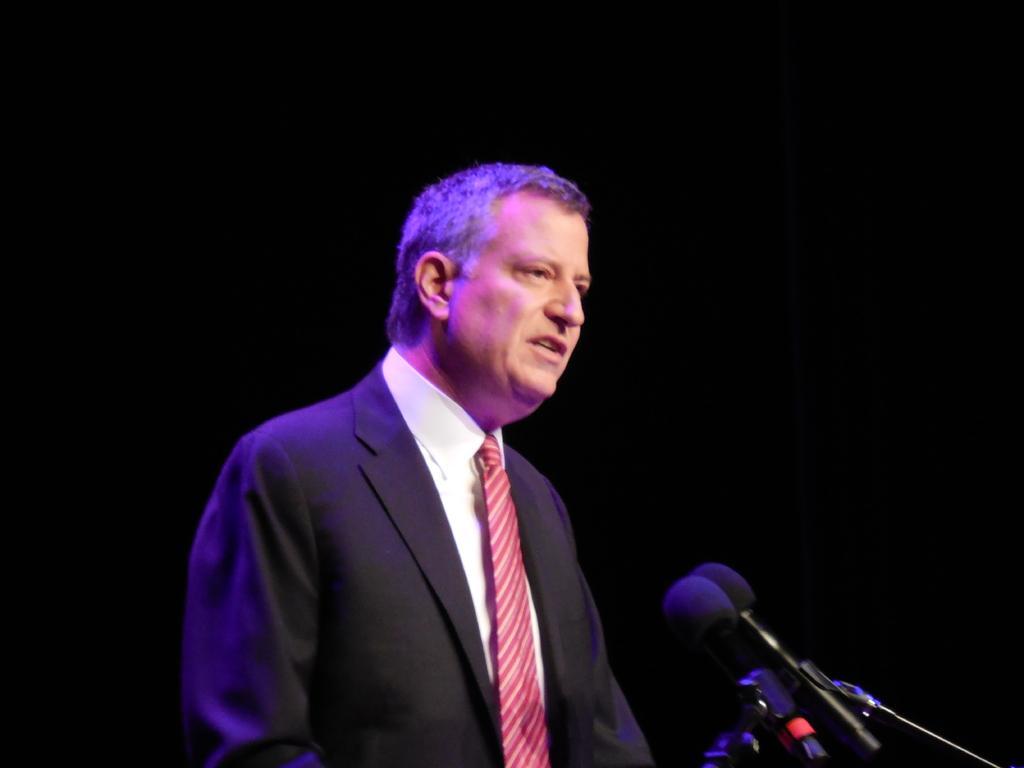Could you give a brief overview of what you see in this image? In the middle of the image a person is standing. In front of him we can see some microphones. 